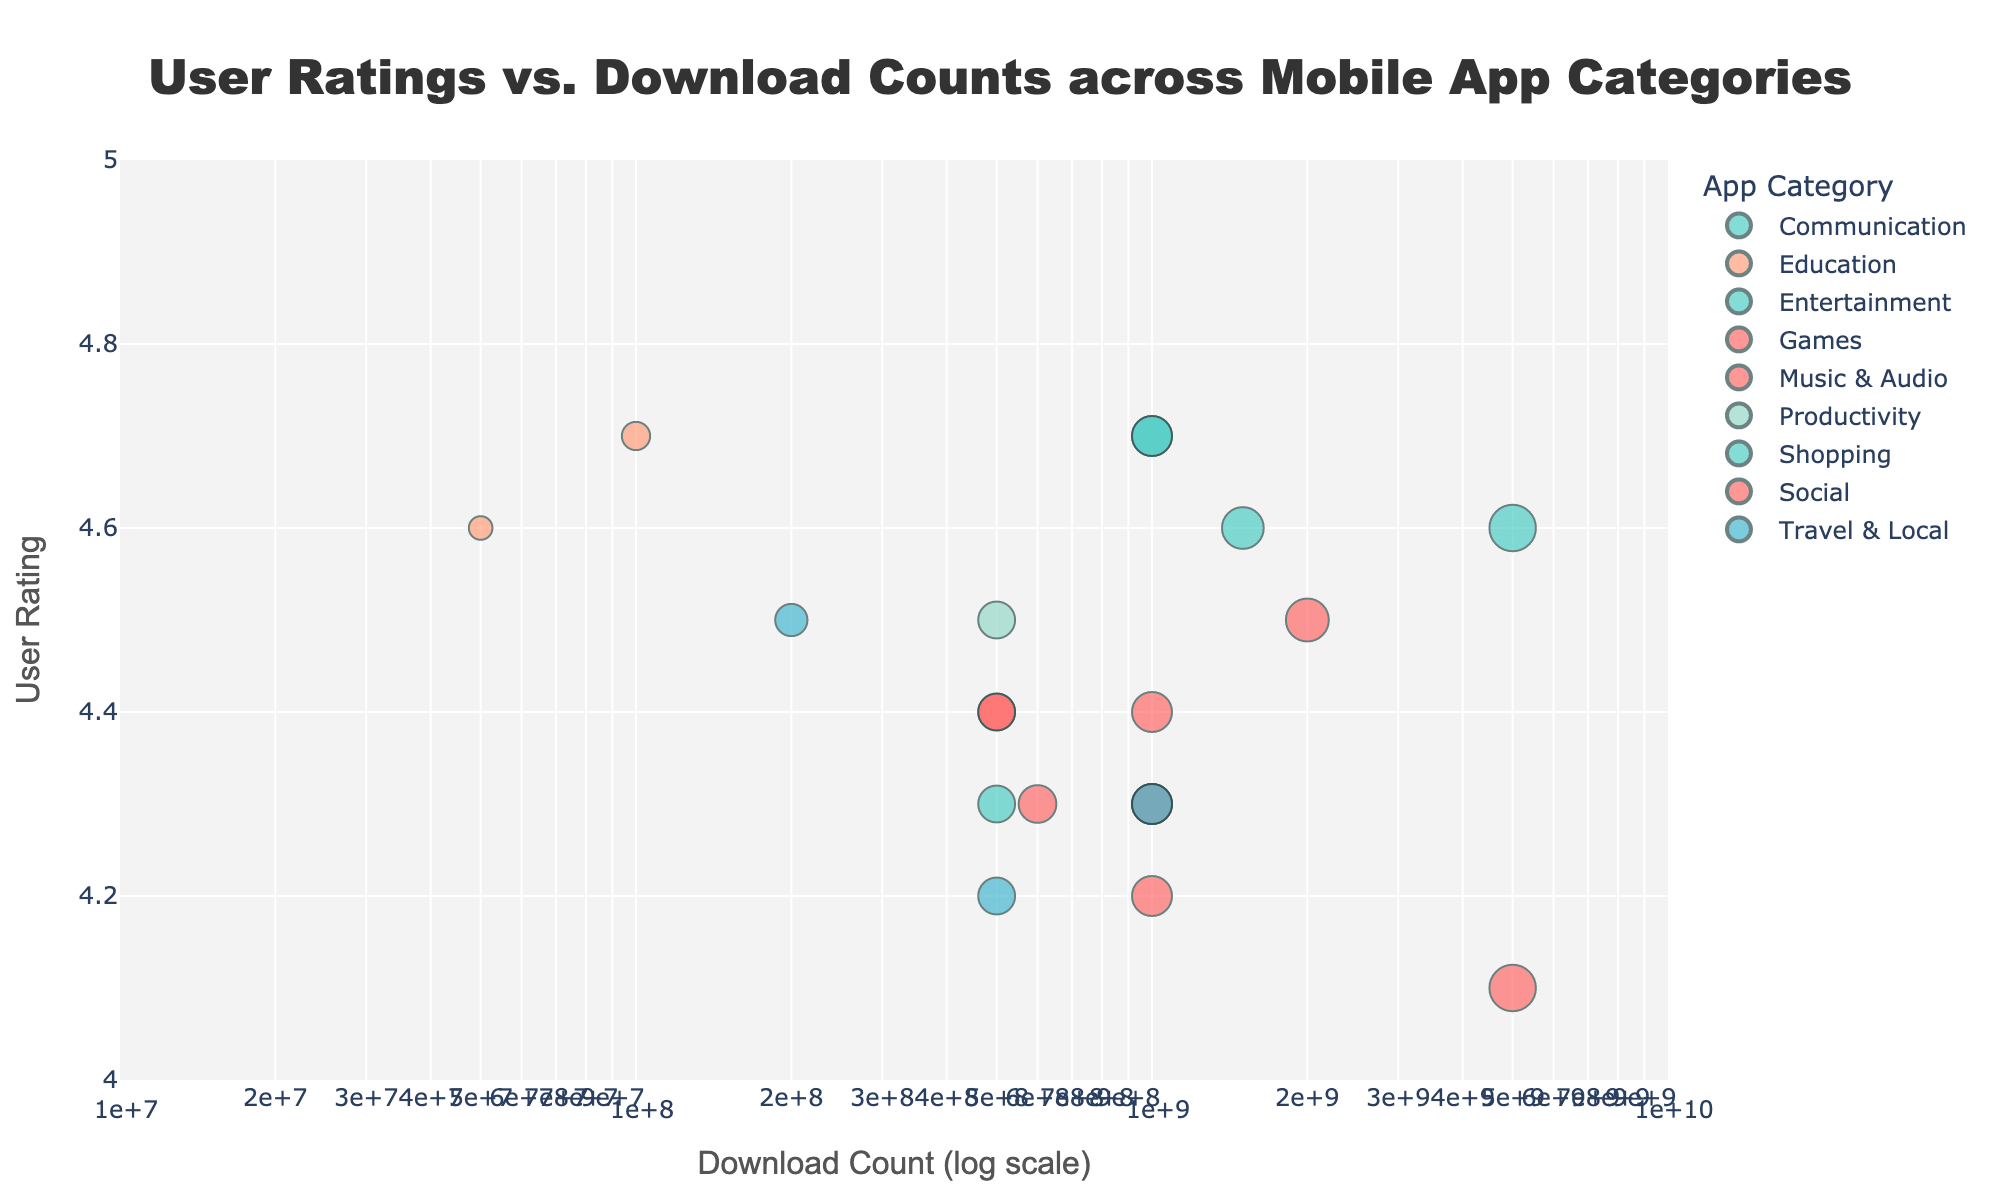What's the title of the plot? The title of the plot is indicated at the top of the figure.
Answer: User Ratings vs. Download Counts across Mobile App Categories What's the x-axis representing, and what's its scale type? The x-axis represents the download count and uses a logarithmic scale.
Answer: Download Count (log scale) What is the range of user ratings shown on the y-axis? The y-axis depicts user ratings, and its range is specified from 4 to 5.
Answer: 4 to 5 Which app category includes an app with the highest download count, and what is that count? The highest download count is 5,000,000,000, and it belongs to a Social app (Facebook).
Answer: Social, 5,000,000,000 Compare the user ratings of WhatsApp and Gmail. Which app has a higher user rating? WhatsApp has a user rating of 4.7, while Gmail has a user rating of 4.6.
Answer: WhatsApp Identify the app with the lowest download count and specify its category and rating. The lowest download count is 50,000,000, and it belongs to Khan Academy in the Education category with a rating of 4.6.
Answer: Khan Academy, Education, 4.6 Which category has more apps with 1 billion or more downloads, Social or Communication? Both Social and Communication categories have two apps each with 1 billion or more downloads (Facebook, Instagram; WhatsApp, Gmail respectively).
Answer: Both What's the average user rating of apps within the Travel & Local category? The Travel & Local category includes Google Maps (4.3), Uber (4.2), and Airbnb (4.5). The average is calculated as (4.3 + 4.2 + 4.5) / 3.
Answer: 4.33 Which app within the Games category has the higher user rating, and what is that rating? In the Games category, Candy Crush Saga has a rating of 4.4 and PUBG Mobile has a rating of 4.3.
Answer: Candy Crush Saga, 4.4 